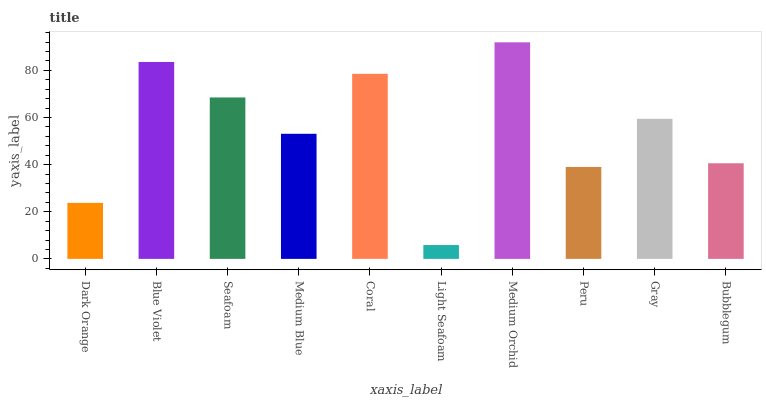Is Light Seafoam the minimum?
Answer yes or no. Yes. Is Medium Orchid the maximum?
Answer yes or no. Yes. Is Blue Violet the minimum?
Answer yes or no. No. Is Blue Violet the maximum?
Answer yes or no. No. Is Blue Violet greater than Dark Orange?
Answer yes or no. Yes. Is Dark Orange less than Blue Violet?
Answer yes or no. Yes. Is Dark Orange greater than Blue Violet?
Answer yes or no. No. Is Blue Violet less than Dark Orange?
Answer yes or no. No. Is Gray the high median?
Answer yes or no. Yes. Is Medium Blue the low median?
Answer yes or no. Yes. Is Seafoam the high median?
Answer yes or no. No. Is Peru the low median?
Answer yes or no. No. 